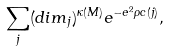Convert formula to latex. <formula><loc_0><loc_0><loc_500><loc_500>\sum _ { j } ( d i m _ { j } ) ^ { \kappa ( M ) } e ^ { - e ^ { 2 } \rho c ( j ) } ,</formula> 